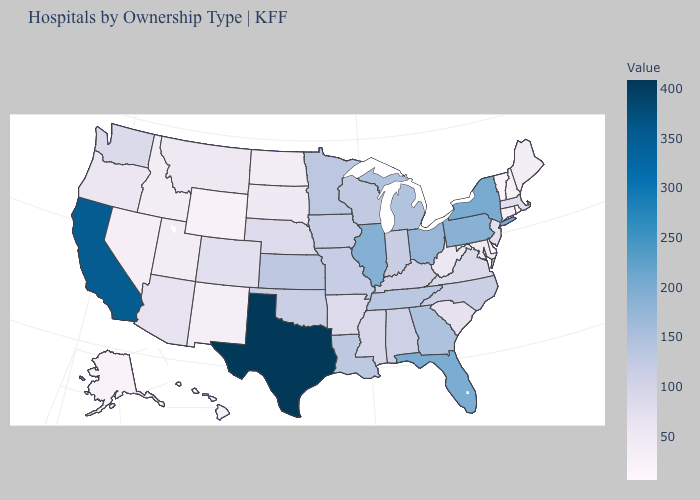Among the states that border North Dakota , does Minnesota have the highest value?
Be succinct. Yes. Does New Mexico have the lowest value in the West?
Be succinct. No. Does California have a higher value than Texas?
Write a very short answer. No. Among the states that border Florida , which have the lowest value?
Keep it brief. Alabama. Among the states that border Tennessee , does Alabama have the highest value?
Write a very short answer. No. 